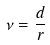Convert formula to latex. <formula><loc_0><loc_0><loc_500><loc_500>\nu = \frac { d } { r }</formula> 